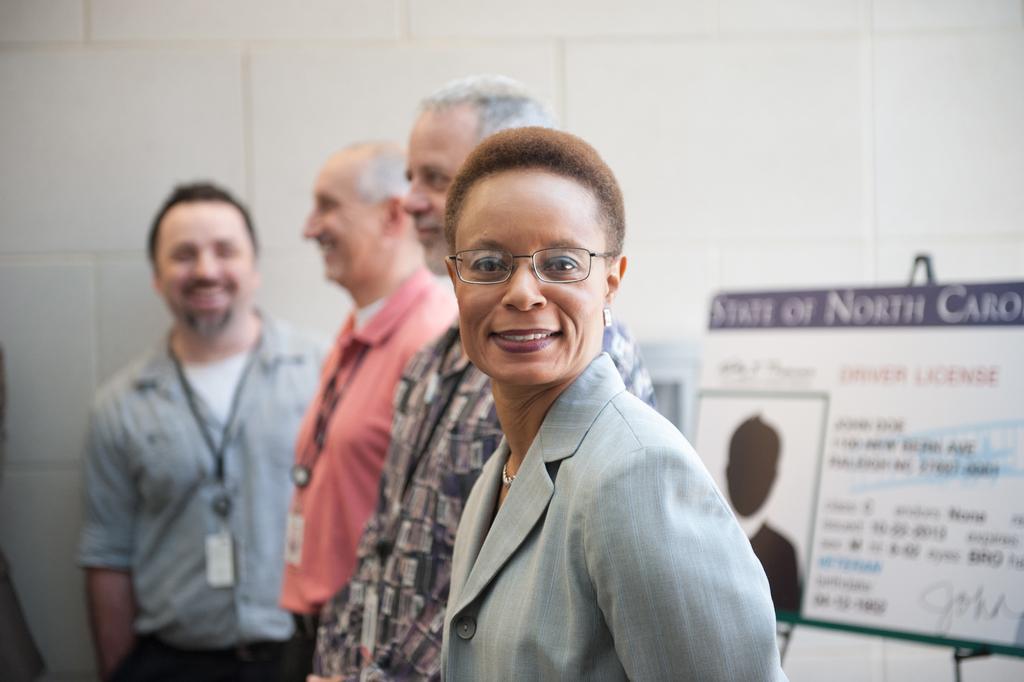Describe this image in one or two sentences. In this image we can see few persons are standing. In the background on the right side we can see a board on a stand and wall. 